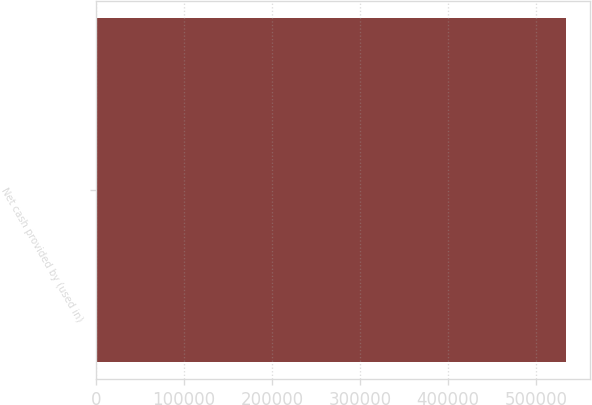Convert chart to OTSL. <chart><loc_0><loc_0><loc_500><loc_500><bar_chart><fcel>Net cash provided by (used in)<nl><fcel>534391<nl></chart> 